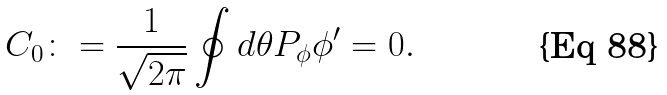<formula> <loc_0><loc_0><loc_500><loc_500>C _ { 0 } \colon = \frac { 1 } { \sqrt { 2 \pi } } \oint d \theta P _ { \phi } \phi ^ { \prime } = 0 .</formula> 